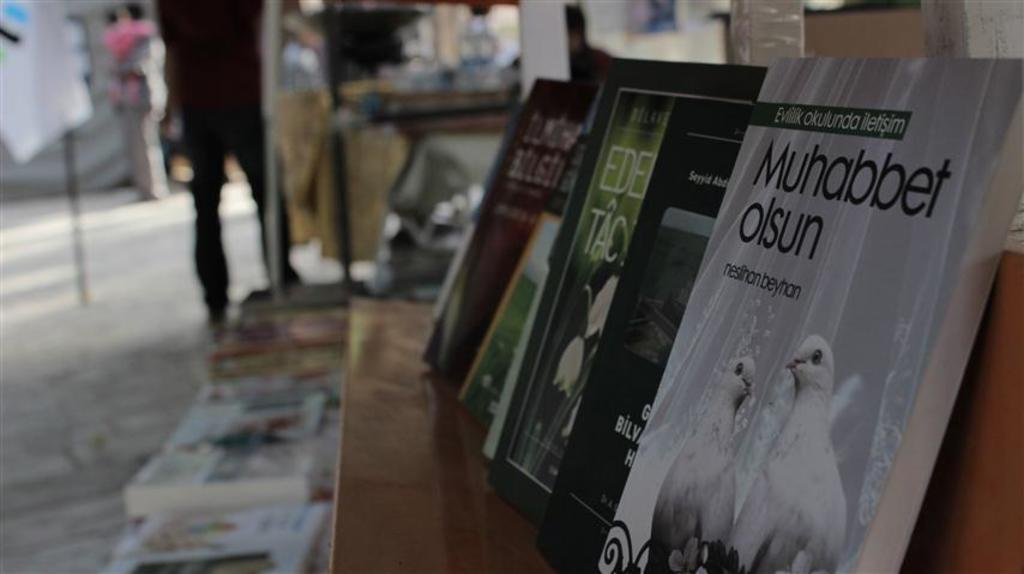<image>
Relay a brief, clear account of the picture shown. A shelf with a book titled Muhabbet olsun on it. 